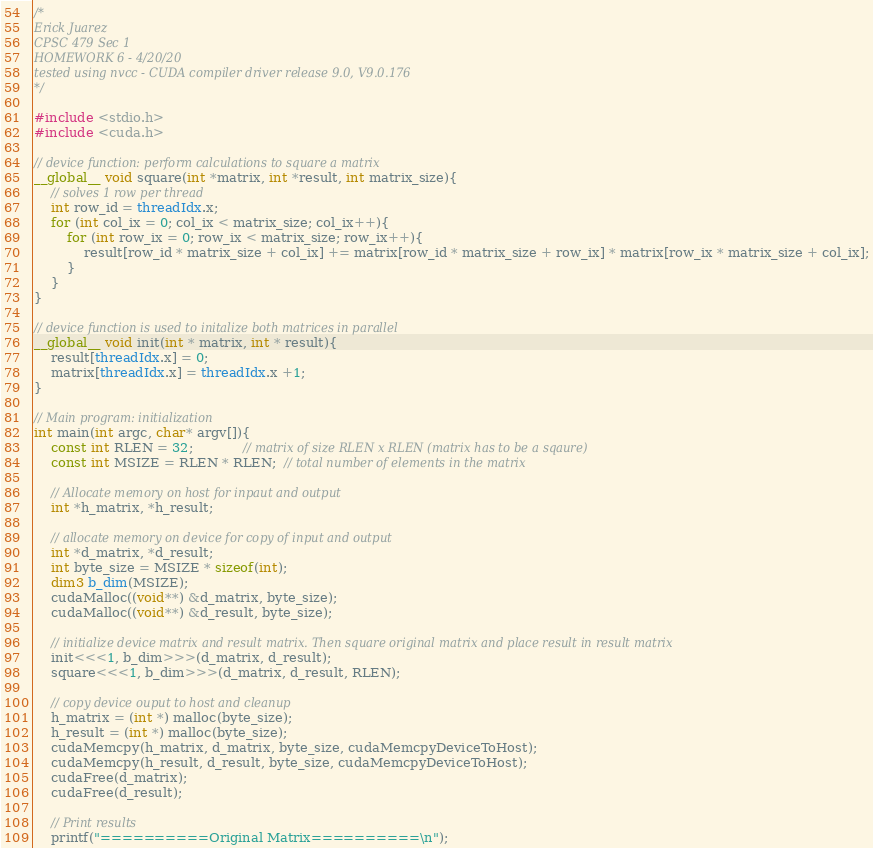Convert code to text. <code><loc_0><loc_0><loc_500><loc_500><_Cuda_>/* 
Erick Juarez
CPSC 479 Sec 1
HOMEWORK 6 - 4/20/20
tested using nvcc - CUDA compiler driver release 9.0, V9.0.176
*/

#include <stdio.h>
#include <cuda.h>

// device function: perform calculations to square a matrix 
__global__ void square(int *matrix, int *result, int matrix_size){
    // solves 1 row per thread 
    int row_id = threadIdx.x; 
    for (int col_ix = 0; col_ix < matrix_size; col_ix++){
        for (int row_ix = 0; row_ix < matrix_size; row_ix++){
            result[row_id * matrix_size + col_ix] += matrix[row_id * matrix_size + row_ix] * matrix[row_ix * matrix_size + col_ix];
        }
    }
}

// device function is used to initalize both matrices in parallel 
__global__ void init(int * matrix, int * result){
    result[threadIdx.x] = 0; 
    matrix[threadIdx.x] = threadIdx.x +1; 
}

// Main program: initialization 
int main(int argc, char* argv[]){  
    const int RLEN = 32;            // matrix of size RLEN x RLEN (matrix has to be a sqaure) 
    const int MSIZE = RLEN * RLEN;  // total number of elements in the matrix 

    // Allocate memory on host for inpaut and output 
    int *h_matrix, *h_result;

    // allocate memory on device for copy of input and output 
    int *d_matrix, *d_result;
    int byte_size = MSIZE * sizeof(int);
    dim3 b_dim(MSIZE);
    cudaMalloc((void**) &d_matrix, byte_size);
    cudaMalloc((void**) &d_result, byte_size);

    // initialize device matrix and result matrix. Then square original matrix and place result in result matrix
    init<<<1, b_dim>>>(d_matrix, d_result);
    square<<<1, b_dim>>>(d_matrix, d_result, RLEN);

    // copy device ouput to host and cleanup 
    h_matrix = (int *) malloc(byte_size);
    h_result = (int *) malloc(byte_size);
    cudaMemcpy(h_matrix, d_matrix, byte_size, cudaMemcpyDeviceToHost);
    cudaMemcpy(h_result, d_result, byte_size, cudaMemcpyDeviceToHost);
    cudaFree(d_matrix);
    cudaFree(d_result);

    // Print results
    printf("==========Original Matrix==========\n");</code> 